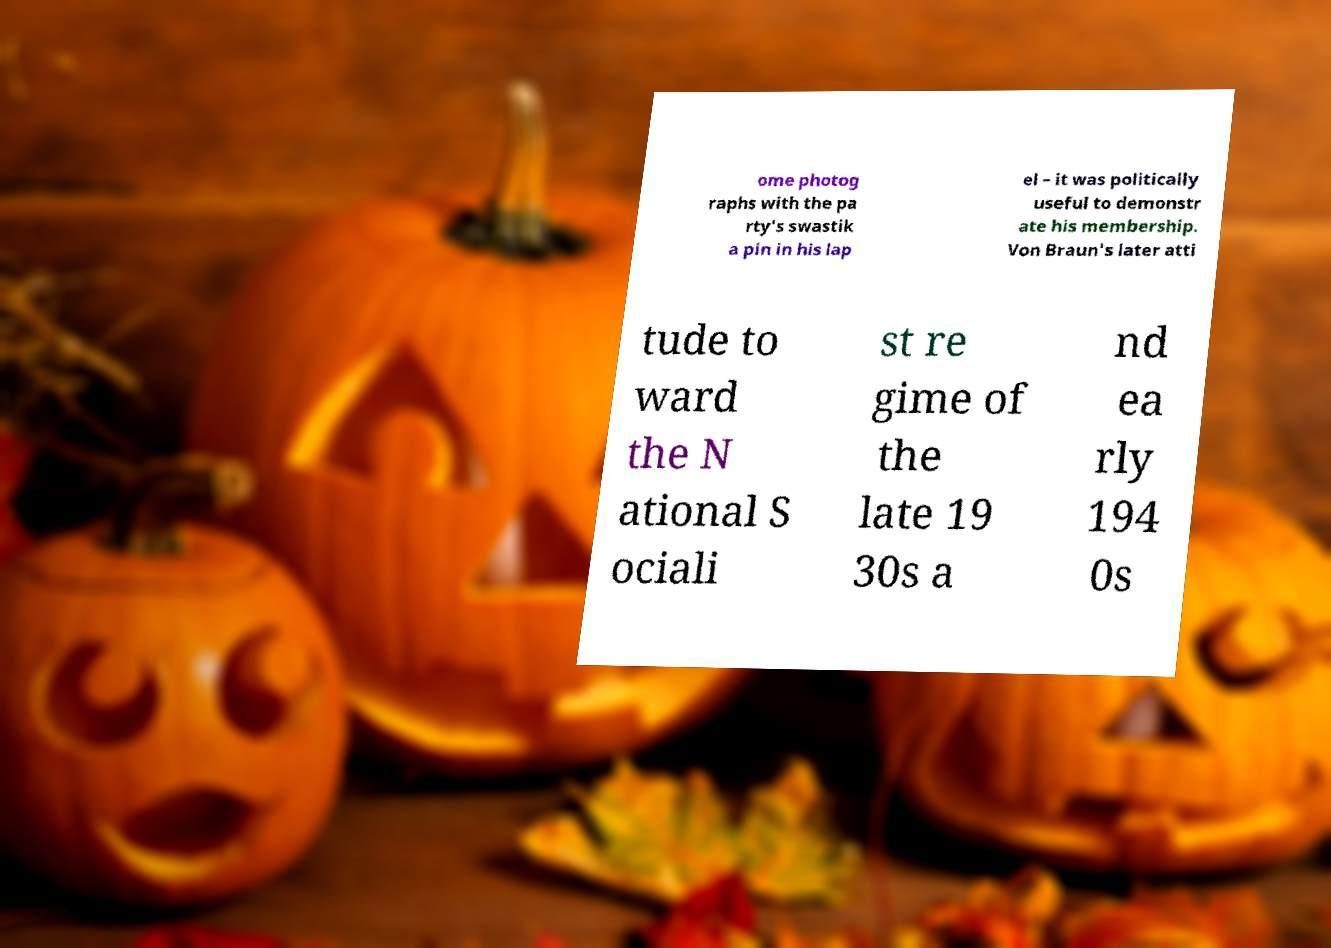Could you extract and type out the text from this image? ome photog raphs with the pa rty's swastik a pin in his lap el – it was politically useful to demonstr ate his membership. Von Braun's later atti tude to ward the N ational S ociali st re gime of the late 19 30s a nd ea rly 194 0s 